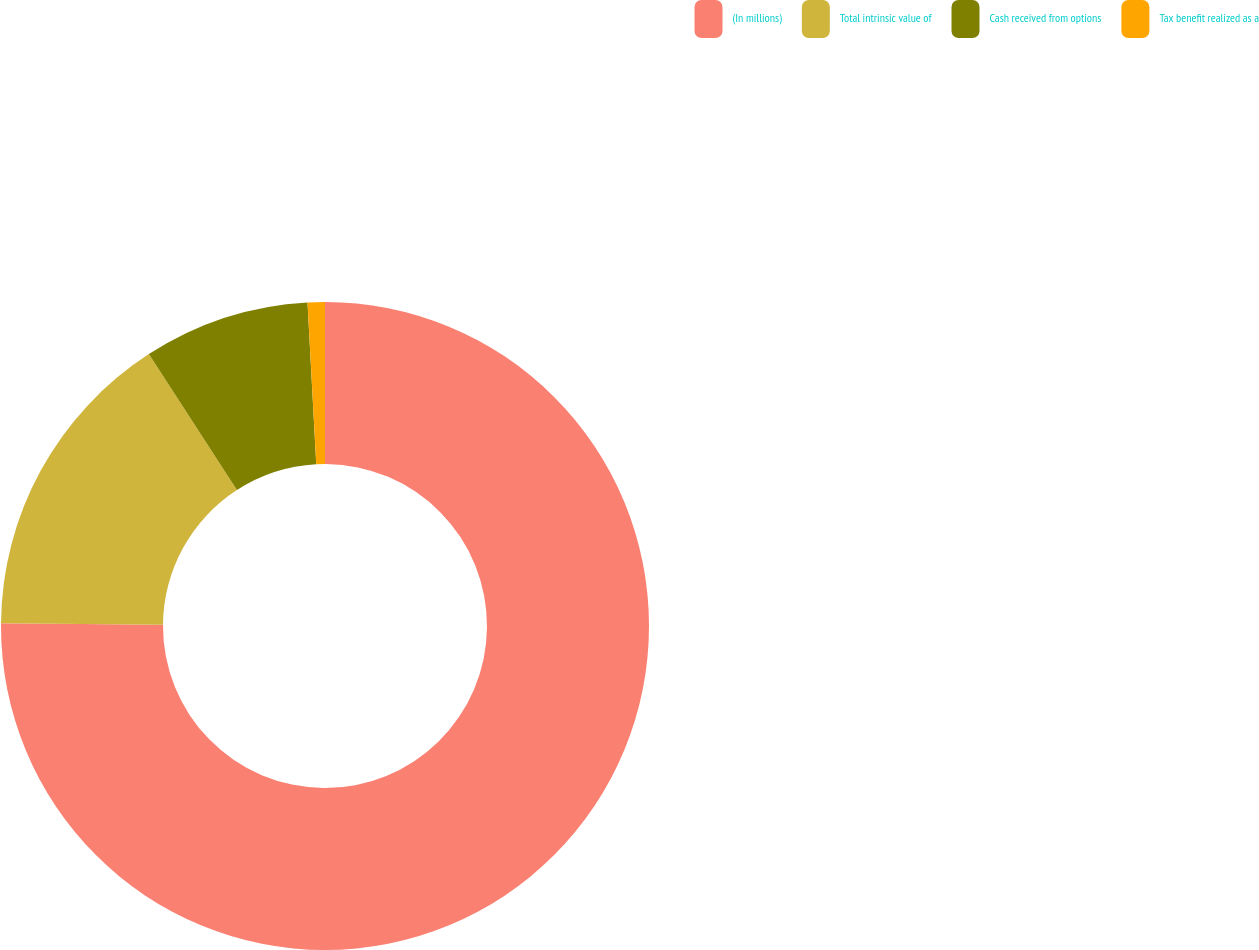<chart> <loc_0><loc_0><loc_500><loc_500><pie_chart><fcel>(In millions)<fcel>Total intrinsic value of<fcel>Cash received from options<fcel>Tax benefit realized as a<nl><fcel>75.14%<fcel>15.72%<fcel>8.29%<fcel>0.86%<nl></chart> 